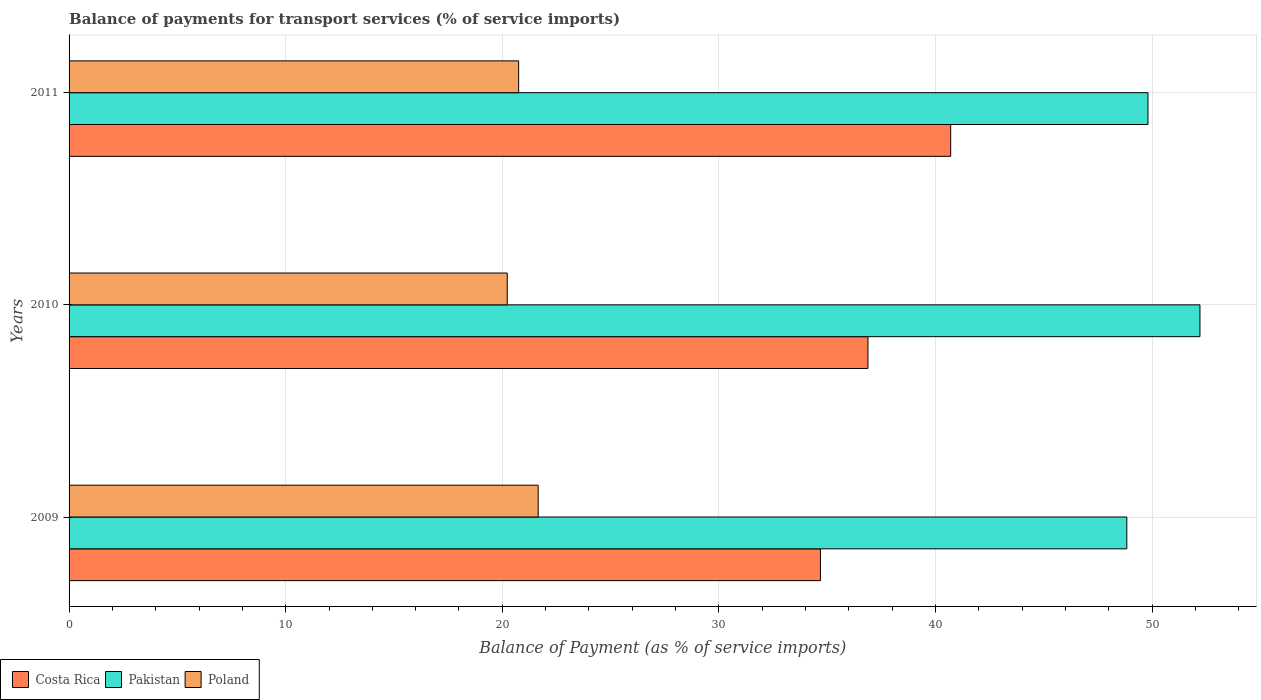How many different coloured bars are there?
Your answer should be very brief. 3. Are the number of bars per tick equal to the number of legend labels?
Your response must be concise. Yes. In how many cases, is the number of bars for a given year not equal to the number of legend labels?
Ensure brevity in your answer.  0. What is the balance of payments for transport services in Costa Rica in 2009?
Your answer should be compact. 34.69. Across all years, what is the maximum balance of payments for transport services in Pakistan?
Give a very brief answer. 52.21. Across all years, what is the minimum balance of payments for transport services in Poland?
Provide a succinct answer. 20.23. In which year was the balance of payments for transport services in Pakistan maximum?
Offer a terse response. 2010. What is the total balance of payments for transport services in Poland in the graph?
Provide a short and direct response. 62.64. What is the difference between the balance of payments for transport services in Pakistan in 2009 and that in 2011?
Your answer should be compact. -0.98. What is the difference between the balance of payments for transport services in Costa Rica in 2009 and the balance of payments for transport services in Poland in 2011?
Provide a succinct answer. 13.93. What is the average balance of payments for transport services in Pakistan per year?
Your response must be concise. 50.28. In the year 2010, what is the difference between the balance of payments for transport services in Poland and balance of payments for transport services in Costa Rica?
Your answer should be compact. -16.65. What is the ratio of the balance of payments for transport services in Poland in 2010 to that in 2011?
Ensure brevity in your answer.  0.97. Is the balance of payments for transport services in Poland in 2009 less than that in 2011?
Offer a very short reply. No. Is the difference between the balance of payments for transport services in Poland in 2009 and 2011 greater than the difference between the balance of payments for transport services in Costa Rica in 2009 and 2011?
Offer a very short reply. Yes. What is the difference between the highest and the second highest balance of payments for transport services in Pakistan?
Provide a short and direct response. 2.4. What is the difference between the highest and the lowest balance of payments for transport services in Costa Rica?
Offer a terse response. 6.01. In how many years, is the balance of payments for transport services in Poland greater than the average balance of payments for transport services in Poland taken over all years?
Give a very brief answer. 1. What does the 1st bar from the top in 2011 represents?
Provide a succinct answer. Poland. What does the 3rd bar from the bottom in 2010 represents?
Provide a succinct answer. Poland. How many bars are there?
Your answer should be compact. 9. How many years are there in the graph?
Offer a terse response. 3. What is the difference between two consecutive major ticks on the X-axis?
Give a very brief answer. 10. Are the values on the major ticks of X-axis written in scientific E-notation?
Provide a short and direct response. No. Where does the legend appear in the graph?
Keep it short and to the point. Bottom left. What is the title of the graph?
Give a very brief answer. Balance of payments for transport services (% of service imports). Does "World" appear as one of the legend labels in the graph?
Your response must be concise. No. What is the label or title of the X-axis?
Keep it short and to the point. Balance of Payment (as % of service imports). What is the label or title of the Y-axis?
Ensure brevity in your answer.  Years. What is the Balance of Payment (as % of service imports) of Costa Rica in 2009?
Offer a very short reply. 34.69. What is the Balance of Payment (as % of service imports) in Pakistan in 2009?
Provide a succinct answer. 48.83. What is the Balance of Payment (as % of service imports) in Poland in 2009?
Your response must be concise. 21.66. What is the Balance of Payment (as % of service imports) in Costa Rica in 2010?
Ensure brevity in your answer.  36.88. What is the Balance of Payment (as % of service imports) in Pakistan in 2010?
Your response must be concise. 52.21. What is the Balance of Payment (as % of service imports) in Poland in 2010?
Give a very brief answer. 20.23. What is the Balance of Payment (as % of service imports) in Costa Rica in 2011?
Keep it short and to the point. 40.7. What is the Balance of Payment (as % of service imports) in Pakistan in 2011?
Provide a succinct answer. 49.81. What is the Balance of Payment (as % of service imports) of Poland in 2011?
Your answer should be compact. 20.75. Across all years, what is the maximum Balance of Payment (as % of service imports) of Costa Rica?
Give a very brief answer. 40.7. Across all years, what is the maximum Balance of Payment (as % of service imports) of Pakistan?
Offer a terse response. 52.21. Across all years, what is the maximum Balance of Payment (as % of service imports) in Poland?
Your response must be concise. 21.66. Across all years, what is the minimum Balance of Payment (as % of service imports) of Costa Rica?
Offer a very short reply. 34.69. Across all years, what is the minimum Balance of Payment (as % of service imports) of Pakistan?
Your answer should be compact. 48.83. Across all years, what is the minimum Balance of Payment (as % of service imports) of Poland?
Provide a short and direct response. 20.23. What is the total Balance of Payment (as % of service imports) in Costa Rica in the graph?
Ensure brevity in your answer.  112.27. What is the total Balance of Payment (as % of service imports) of Pakistan in the graph?
Your answer should be very brief. 150.85. What is the total Balance of Payment (as % of service imports) in Poland in the graph?
Provide a short and direct response. 62.64. What is the difference between the Balance of Payment (as % of service imports) of Costa Rica in 2009 and that in 2010?
Your answer should be compact. -2.19. What is the difference between the Balance of Payment (as % of service imports) of Pakistan in 2009 and that in 2010?
Your answer should be compact. -3.38. What is the difference between the Balance of Payment (as % of service imports) of Poland in 2009 and that in 2010?
Ensure brevity in your answer.  1.43. What is the difference between the Balance of Payment (as % of service imports) of Costa Rica in 2009 and that in 2011?
Provide a short and direct response. -6.01. What is the difference between the Balance of Payment (as % of service imports) in Pakistan in 2009 and that in 2011?
Ensure brevity in your answer.  -0.98. What is the difference between the Balance of Payment (as % of service imports) in Poland in 2009 and that in 2011?
Keep it short and to the point. 0.9. What is the difference between the Balance of Payment (as % of service imports) of Costa Rica in 2010 and that in 2011?
Give a very brief answer. -3.82. What is the difference between the Balance of Payment (as % of service imports) in Pakistan in 2010 and that in 2011?
Your response must be concise. 2.4. What is the difference between the Balance of Payment (as % of service imports) of Poland in 2010 and that in 2011?
Make the answer very short. -0.53. What is the difference between the Balance of Payment (as % of service imports) of Costa Rica in 2009 and the Balance of Payment (as % of service imports) of Pakistan in 2010?
Your answer should be compact. -17.52. What is the difference between the Balance of Payment (as % of service imports) in Costa Rica in 2009 and the Balance of Payment (as % of service imports) in Poland in 2010?
Keep it short and to the point. 14.46. What is the difference between the Balance of Payment (as % of service imports) in Pakistan in 2009 and the Balance of Payment (as % of service imports) in Poland in 2010?
Your answer should be compact. 28.6. What is the difference between the Balance of Payment (as % of service imports) in Costa Rica in 2009 and the Balance of Payment (as % of service imports) in Pakistan in 2011?
Give a very brief answer. -15.12. What is the difference between the Balance of Payment (as % of service imports) of Costa Rica in 2009 and the Balance of Payment (as % of service imports) of Poland in 2011?
Ensure brevity in your answer.  13.93. What is the difference between the Balance of Payment (as % of service imports) in Pakistan in 2009 and the Balance of Payment (as % of service imports) in Poland in 2011?
Ensure brevity in your answer.  28.08. What is the difference between the Balance of Payment (as % of service imports) in Costa Rica in 2010 and the Balance of Payment (as % of service imports) in Pakistan in 2011?
Offer a very short reply. -12.93. What is the difference between the Balance of Payment (as % of service imports) in Costa Rica in 2010 and the Balance of Payment (as % of service imports) in Poland in 2011?
Provide a succinct answer. 16.13. What is the difference between the Balance of Payment (as % of service imports) of Pakistan in 2010 and the Balance of Payment (as % of service imports) of Poland in 2011?
Make the answer very short. 31.45. What is the average Balance of Payment (as % of service imports) of Costa Rica per year?
Provide a succinct answer. 37.42. What is the average Balance of Payment (as % of service imports) in Pakistan per year?
Your response must be concise. 50.28. What is the average Balance of Payment (as % of service imports) in Poland per year?
Make the answer very short. 20.88. In the year 2009, what is the difference between the Balance of Payment (as % of service imports) of Costa Rica and Balance of Payment (as % of service imports) of Pakistan?
Your answer should be very brief. -14.14. In the year 2009, what is the difference between the Balance of Payment (as % of service imports) of Costa Rica and Balance of Payment (as % of service imports) of Poland?
Make the answer very short. 13.03. In the year 2009, what is the difference between the Balance of Payment (as % of service imports) of Pakistan and Balance of Payment (as % of service imports) of Poland?
Give a very brief answer. 27.18. In the year 2010, what is the difference between the Balance of Payment (as % of service imports) of Costa Rica and Balance of Payment (as % of service imports) of Pakistan?
Make the answer very short. -15.33. In the year 2010, what is the difference between the Balance of Payment (as % of service imports) of Costa Rica and Balance of Payment (as % of service imports) of Poland?
Provide a succinct answer. 16.65. In the year 2010, what is the difference between the Balance of Payment (as % of service imports) in Pakistan and Balance of Payment (as % of service imports) in Poland?
Offer a terse response. 31.98. In the year 2011, what is the difference between the Balance of Payment (as % of service imports) of Costa Rica and Balance of Payment (as % of service imports) of Pakistan?
Your response must be concise. -9.11. In the year 2011, what is the difference between the Balance of Payment (as % of service imports) of Costa Rica and Balance of Payment (as % of service imports) of Poland?
Make the answer very short. 19.95. In the year 2011, what is the difference between the Balance of Payment (as % of service imports) in Pakistan and Balance of Payment (as % of service imports) in Poland?
Make the answer very short. 29.05. What is the ratio of the Balance of Payment (as % of service imports) of Costa Rica in 2009 to that in 2010?
Offer a very short reply. 0.94. What is the ratio of the Balance of Payment (as % of service imports) of Pakistan in 2009 to that in 2010?
Keep it short and to the point. 0.94. What is the ratio of the Balance of Payment (as % of service imports) in Poland in 2009 to that in 2010?
Offer a very short reply. 1.07. What is the ratio of the Balance of Payment (as % of service imports) of Costa Rica in 2009 to that in 2011?
Your answer should be compact. 0.85. What is the ratio of the Balance of Payment (as % of service imports) of Pakistan in 2009 to that in 2011?
Keep it short and to the point. 0.98. What is the ratio of the Balance of Payment (as % of service imports) of Poland in 2009 to that in 2011?
Offer a very short reply. 1.04. What is the ratio of the Balance of Payment (as % of service imports) in Costa Rica in 2010 to that in 2011?
Provide a short and direct response. 0.91. What is the ratio of the Balance of Payment (as % of service imports) in Pakistan in 2010 to that in 2011?
Your answer should be compact. 1.05. What is the ratio of the Balance of Payment (as % of service imports) of Poland in 2010 to that in 2011?
Keep it short and to the point. 0.97. What is the difference between the highest and the second highest Balance of Payment (as % of service imports) in Costa Rica?
Provide a short and direct response. 3.82. What is the difference between the highest and the second highest Balance of Payment (as % of service imports) in Pakistan?
Your answer should be very brief. 2.4. What is the difference between the highest and the second highest Balance of Payment (as % of service imports) of Poland?
Provide a short and direct response. 0.9. What is the difference between the highest and the lowest Balance of Payment (as % of service imports) in Costa Rica?
Give a very brief answer. 6.01. What is the difference between the highest and the lowest Balance of Payment (as % of service imports) of Pakistan?
Your response must be concise. 3.38. What is the difference between the highest and the lowest Balance of Payment (as % of service imports) in Poland?
Give a very brief answer. 1.43. 